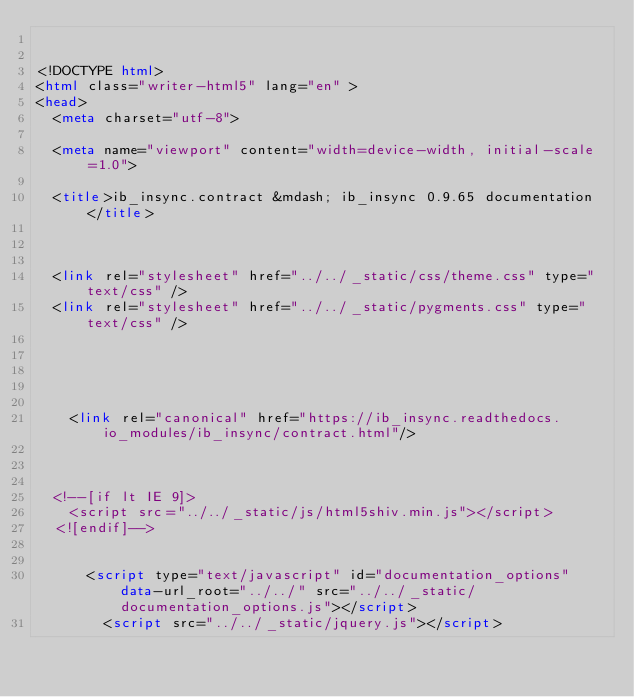<code> <loc_0><loc_0><loc_500><loc_500><_HTML_>

<!DOCTYPE html>
<html class="writer-html5" lang="en" >
<head>
  <meta charset="utf-8">
  
  <meta name="viewport" content="width=device-width, initial-scale=1.0">
  
  <title>ib_insync.contract &mdash; ib_insync 0.9.65 documentation</title>
  

  
  <link rel="stylesheet" href="../../_static/css/theme.css" type="text/css" />
  <link rel="stylesheet" href="../../_static/pygments.css" type="text/css" />

  
  
  
  
    <link rel="canonical" href="https://ib_insync.readthedocs.io_modules/ib_insync/contract.html"/>
  

  
  <!--[if lt IE 9]>
    <script src="../../_static/js/html5shiv.min.js"></script>
  <![endif]-->
  
    
      <script type="text/javascript" id="documentation_options" data-url_root="../../" src="../../_static/documentation_options.js"></script>
        <script src="../../_static/jquery.js"></script></code> 